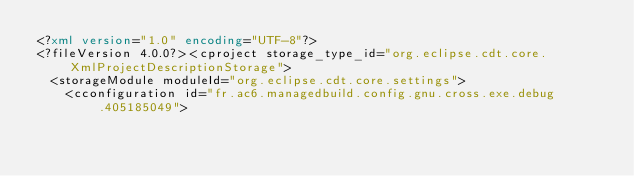<code> <loc_0><loc_0><loc_500><loc_500><_XML_><?xml version="1.0" encoding="UTF-8"?>
<?fileVersion 4.0.0?><cproject storage_type_id="org.eclipse.cdt.core.XmlProjectDescriptionStorage">
	<storageModule moduleId="org.eclipse.cdt.core.settings">
		<cconfiguration id="fr.ac6.managedbuild.config.gnu.cross.exe.debug.405185049"></code> 